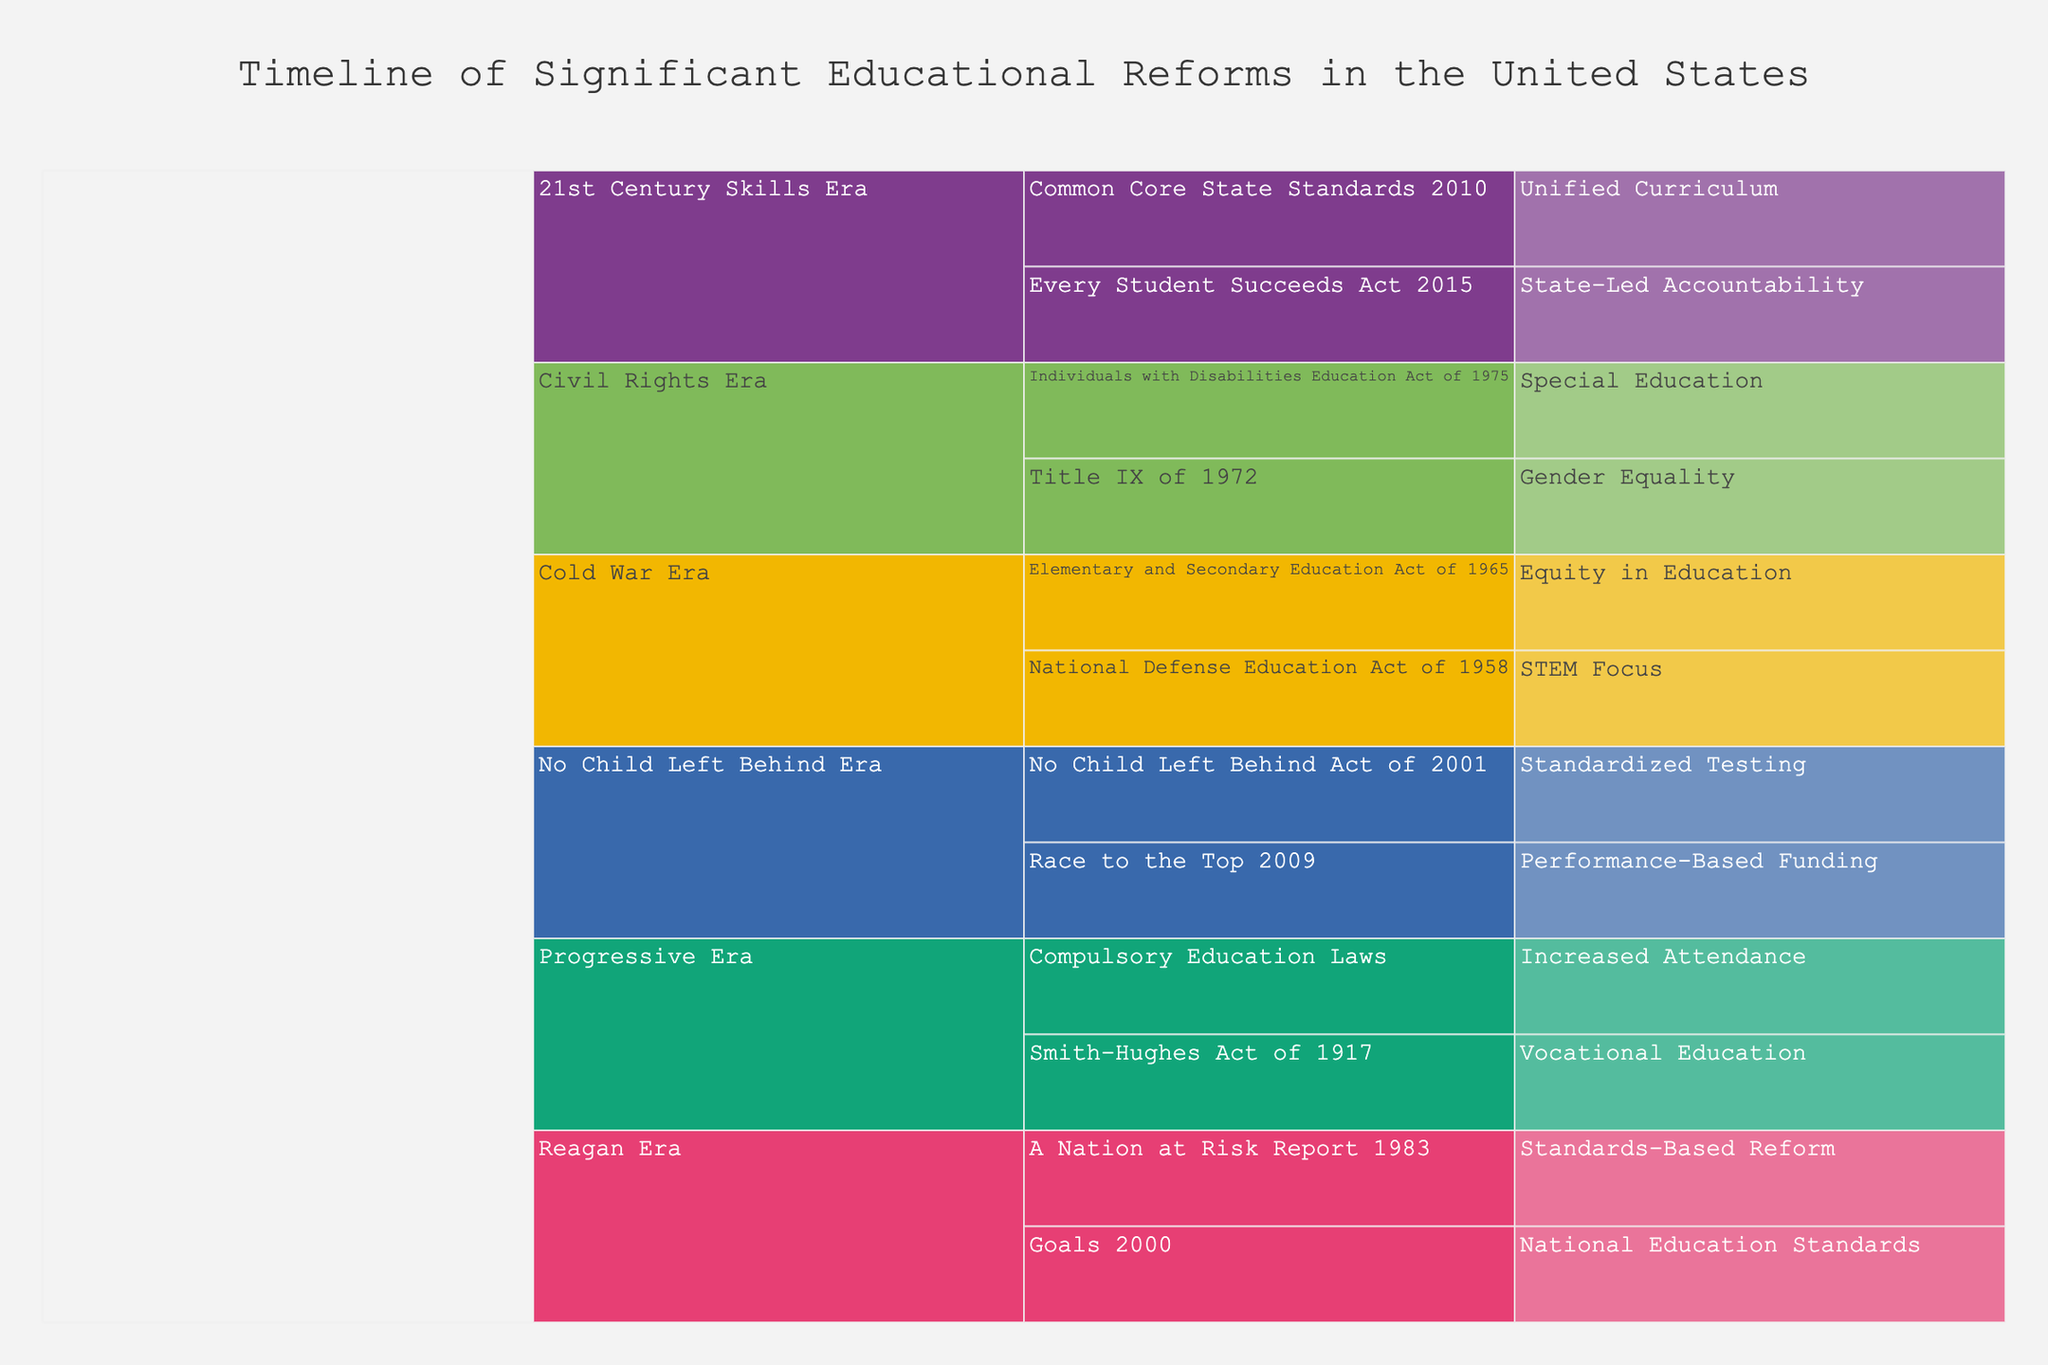What is the title of the icicle chart? The title is displayed prominently at the top of the chart.
Answer: Timeline of Significant Educational Reforms in the United States What era has the most educational reforms listed? To determine this, count the number of reforms listed under each era. The era with the most entries has the most reforms.
Answer: Progressive Era Which reforms are categorized under the Cold War Era? Look at the section of the icicle chart labeled "Cold War Era" and list the reforms under it.
Answer: National Defense Education Act of 1958, Elementary and Secondary Education Act of 1965 How many educational reforms are shown for the Civil Rights Era? Count the number of reforms under the "Civil Rights Era" section of the chart.
Answer: Two What impact is associated with the Title IX of 1972 reform? Find the "Title IX of 1972" under the Civil Rights Era section and note its associated impact.
Answer: Gender Equality Which era includes the reform that focuses on performance-based funding? Locate the "Performance-Based Funding" impact and trace it back to its associated era.
Answer: No Child Left Behind Era Compare the Progressive Era and the Reagan Era in terms of their impact categories. Identify all impact categories listed under the Progressive Era and the Reagan Era, then compare the two lists.
Answer: The Progressive Era has Vocational Education and Increased Attendance, while the Reagan Era has Standards-Based Reform and National Education Standards How many reforms focus on the theme of standardized testing? Count the number of impacts labeled as "Standardized Testing" across all eras.
Answer: One Which era precedes the "21st Century Skills Era"? Look at the sequence of eras in the chart and identify the era immediately before the "21st Century Skills Era."
Answer: No Child Left Behind Era What are the impacts related to educational equity listed in the chart? Scan through the entire chart for impacts involving educational equity and list the corresponding reforms.
Answer: Equity in Education (Elementary and Secondary Education Act of 1965), Special Education (Individuals with Disabilities Education Act of 1975), State-Led Accountability (Every Student Succeeds Act 2015) 